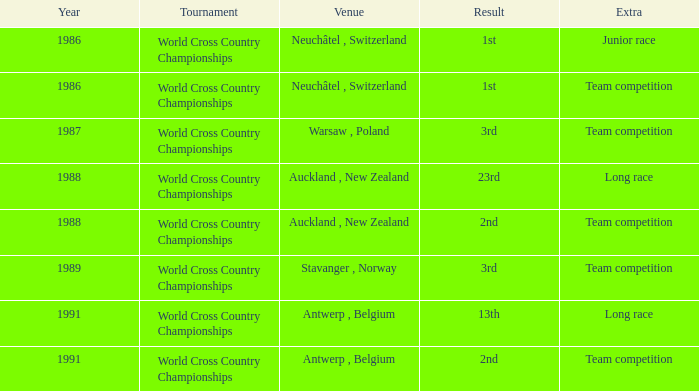Which venue had an extra of Team Competition and a result of 1st? Neuchâtel , Switzerland. 